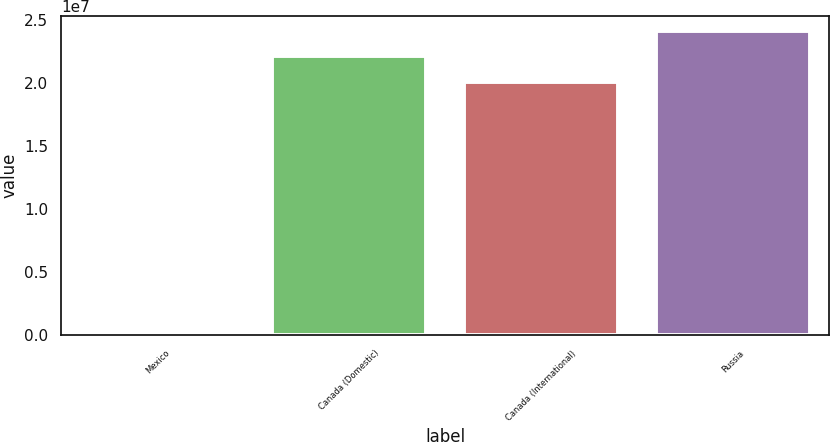Convert chart to OTSL. <chart><loc_0><loc_0><loc_500><loc_500><bar_chart><fcel>Mexico<fcel>Canada (Domestic)<fcel>Canada (International)<fcel>Russia<nl><fcel>2014<fcel>2.2115e+07<fcel>2.0102e+07<fcel>2.4128e+07<nl></chart> 